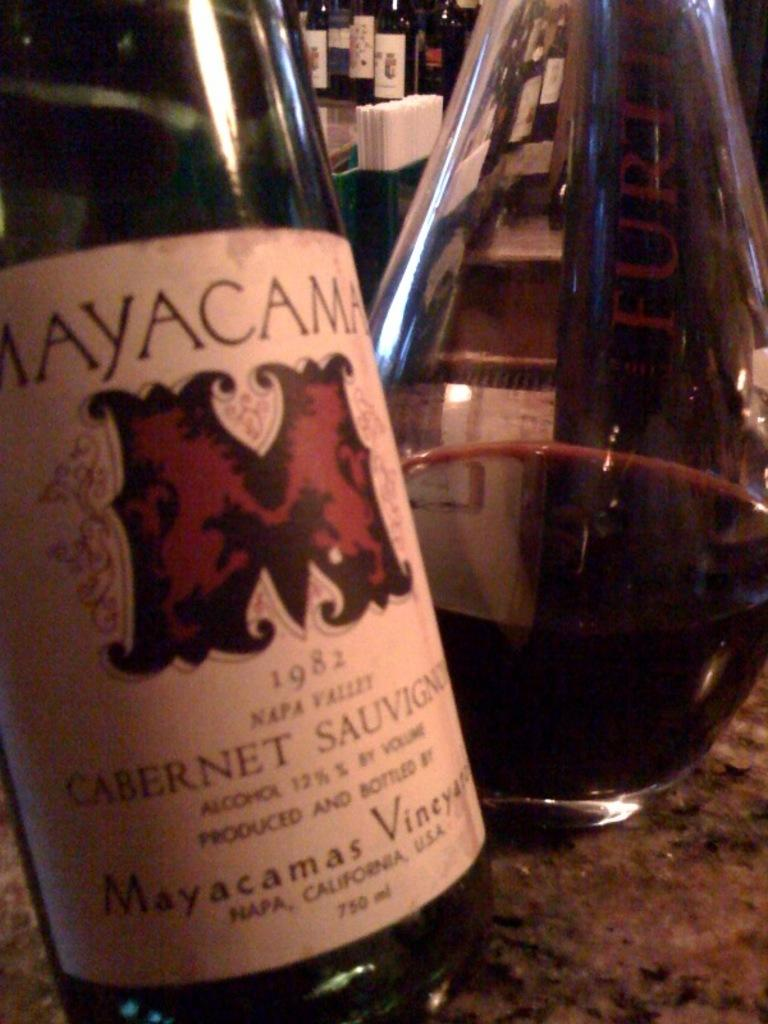Provide a one-sentence caption for the provided image. Mayacama Cabernet Sauvignon 1982 wine bottle in front of a glass bottle on a bar. 